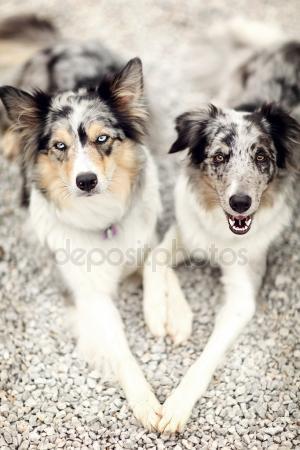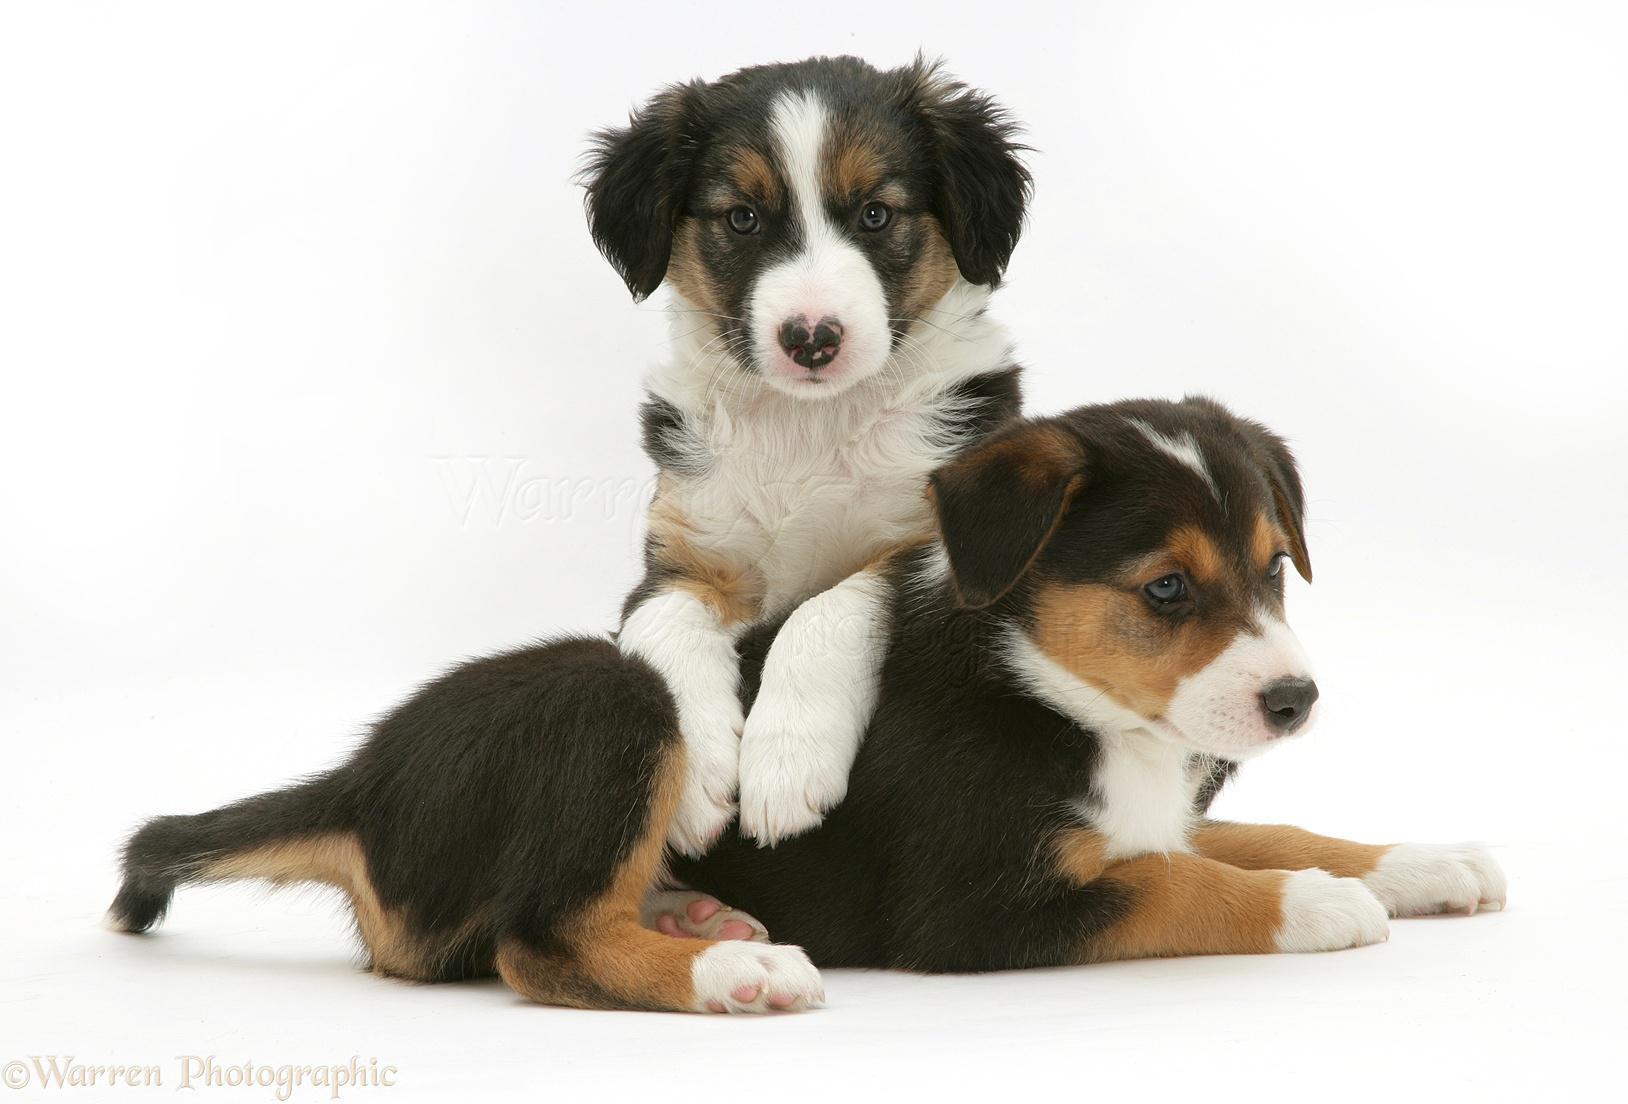The first image is the image on the left, the second image is the image on the right. Assess this claim about the two images: "The right image contains exactly two dogs.". Correct or not? Answer yes or no. Yes. 